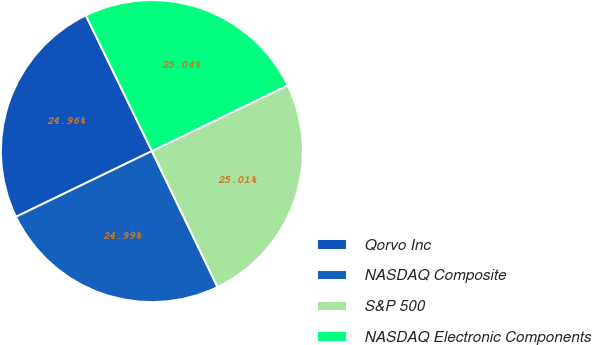Convert chart to OTSL. <chart><loc_0><loc_0><loc_500><loc_500><pie_chart><fcel>Qorvo Inc<fcel>NASDAQ Composite<fcel>S&P 500<fcel>NASDAQ Electronic Components<nl><fcel>24.96%<fcel>24.99%<fcel>25.01%<fcel>25.04%<nl></chart> 